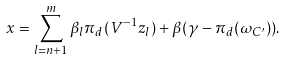Convert formula to latex. <formula><loc_0><loc_0><loc_500><loc_500>x = \sum _ { l = n + 1 } ^ { m } \beta _ { l } \pi _ { d } ( V ^ { - 1 } z _ { l } ) + \beta ( \gamma - \pi _ { d } ( \omega _ { C ^ { \prime } } ) ) .</formula> 